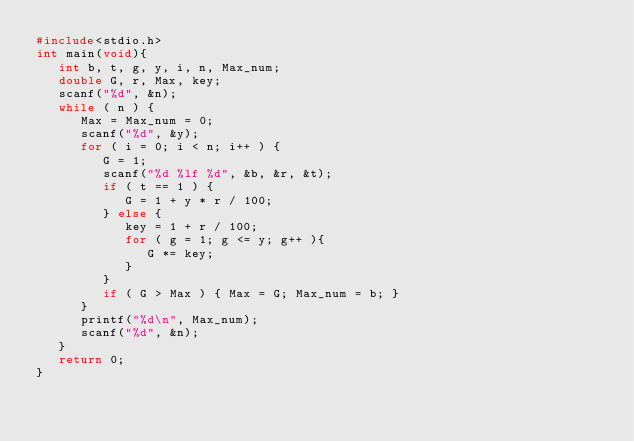Convert code to text. <code><loc_0><loc_0><loc_500><loc_500><_C_>#include<stdio.h>
int main(void){
   int b, t, g, y, i, n, Max_num;
   double G, r, Max, key;
   scanf("%d", &n);
   while ( n ) {
      Max = Max_num = 0;
      scanf("%d", &y);
      for ( i = 0; i < n; i++ ) {
         G = 1;
         scanf("%d %lf %d", &b, &r, &t);
         if ( t == 1 ) {
            G = 1 + y * r / 100;
         } else {
            key = 1 + r / 100;
            for ( g = 1; g <= y; g++ ){
               G *= key;
            }
         }
         if ( G > Max ) { Max = G; Max_num = b; }
      }
      printf("%d\n", Max_num);
      scanf("%d", &n);
   }
   return 0;
}</code> 